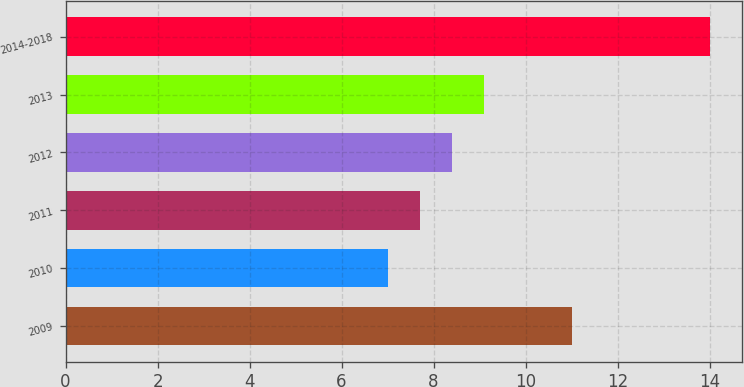Convert chart. <chart><loc_0><loc_0><loc_500><loc_500><bar_chart><fcel>2009<fcel>2010<fcel>2011<fcel>2012<fcel>2013<fcel>2014-2018<nl><fcel>11<fcel>7<fcel>7.7<fcel>8.4<fcel>9.1<fcel>14<nl></chart> 